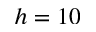Convert formula to latex. <formula><loc_0><loc_0><loc_500><loc_500>h = 1 0</formula> 